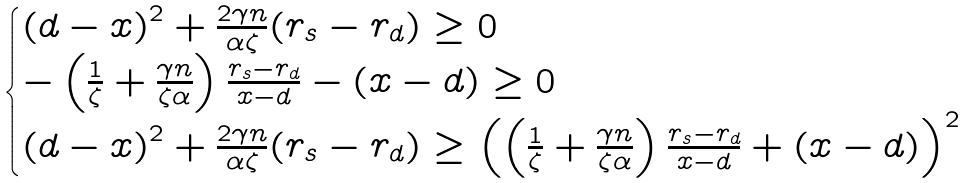<formula> <loc_0><loc_0><loc_500><loc_500>\begin{cases} \left ( d - x \right ) ^ { 2 } + \frac { 2 \gamma n } { \alpha \zeta } ( r _ { s } - r _ { d } ) \geq 0 \\ - \left ( \frac { 1 } { \zeta } + \frac { \gamma n } { \zeta \alpha } \right ) \frac { r _ { s } - r _ { d } } { x - d } - \left ( x - d \right ) \geq 0 \\ \left ( d - x \right ) ^ { 2 } + \frac { 2 \gamma n } { \alpha \zeta } ( r _ { s } - r _ { d } ) \geq \left ( \left ( \frac { 1 } { \zeta } + \frac { \gamma n } { \zeta \alpha } \right ) \frac { r _ { s } - r _ { d } } { x - d } + \left ( x - d \right ) \right ) ^ { 2 } \end{cases}</formula> 